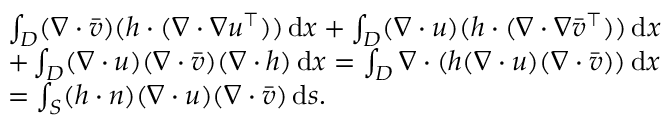<formula> <loc_0><loc_0><loc_500><loc_500>\begin{array} { r l } & { \int _ { D } ( \nabla \cdot \bar { v } ) ( h \cdot ( \nabla \cdot \nabla u ^ { \top } ) ) \, d x + \int _ { D } ( \nabla \cdot u ) ( h \cdot ( \nabla \cdot \nabla \bar { v } ^ { \top } ) ) \, d x } \\ & { + \int _ { D } ( \nabla \cdot u ) ( \nabla \cdot \bar { v } ) ( \nabla \cdot h ) \, d x = \int _ { D } \nabla \cdot ( h ( \nabla \cdot u ) ( \nabla \cdot \bar { v } ) ) \, d x } \\ & { = \int _ { S } ( h \cdot n ) ( \nabla \cdot u ) ( \nabla \cdot \bar { v } ) \, d s . } \end{array}</formula> 